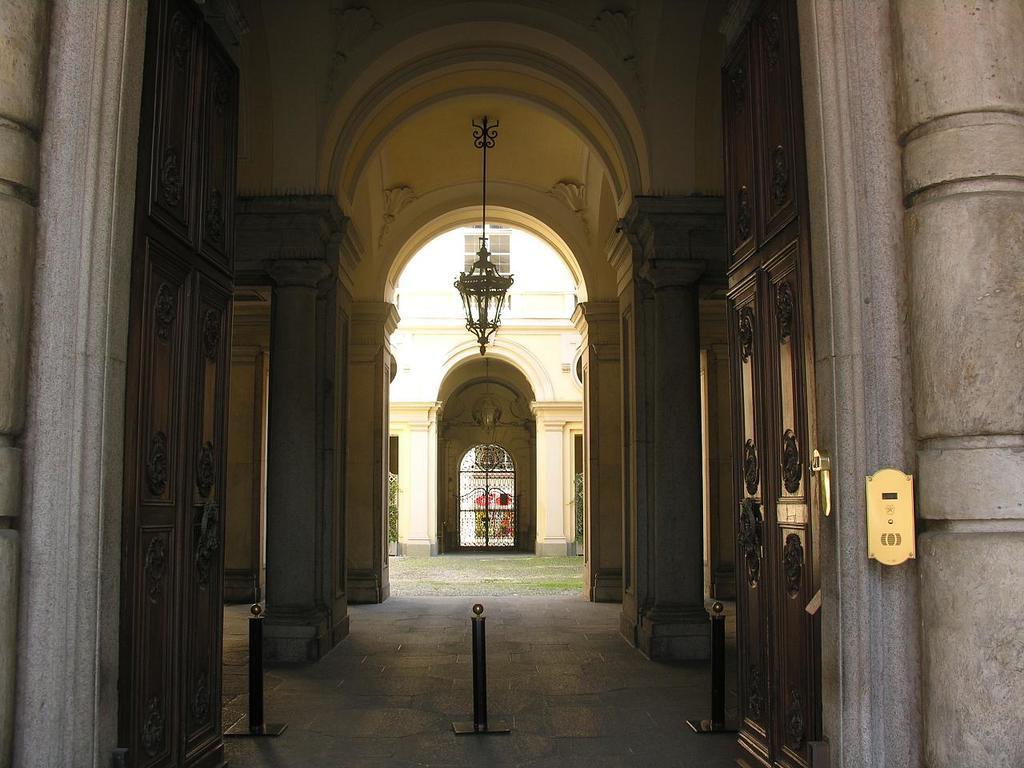Please provide a concise description of this image. In this image we can see the entrance gate and something is hanging from the seal. 